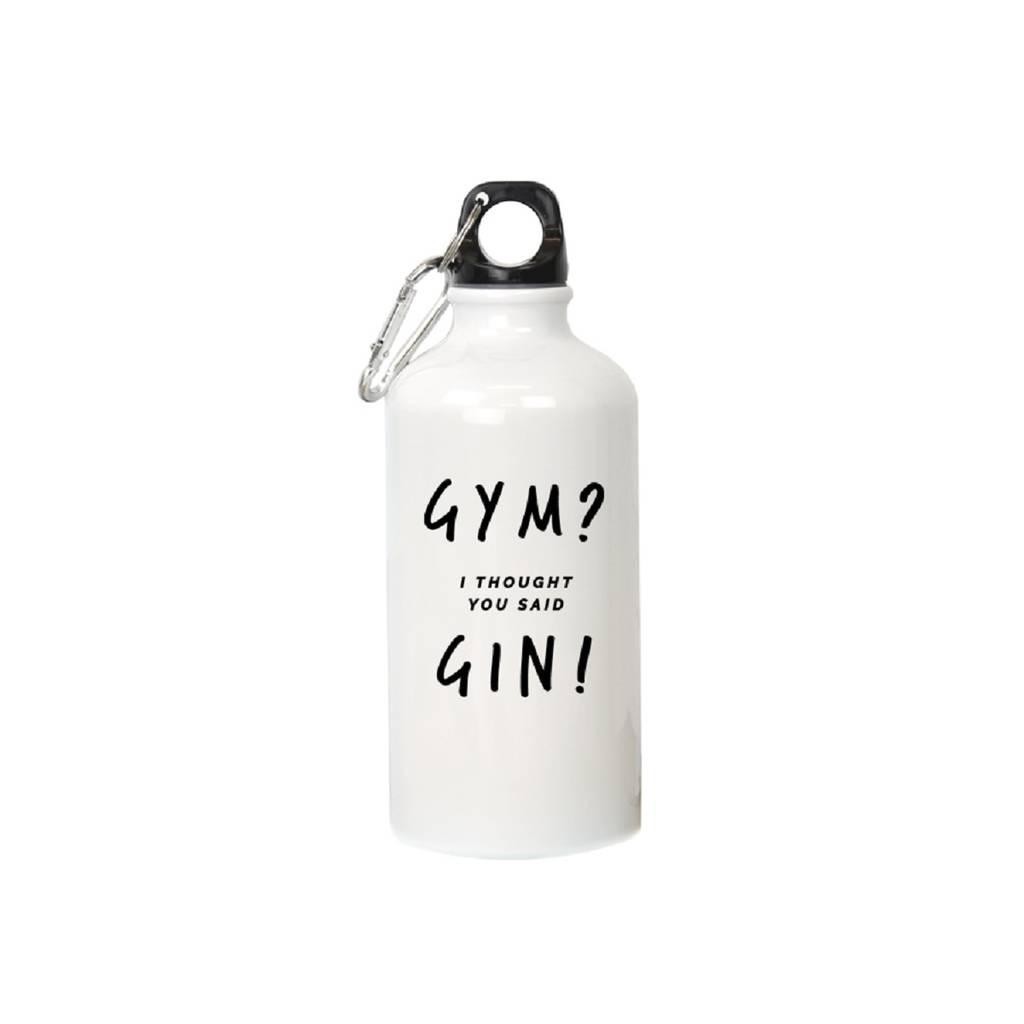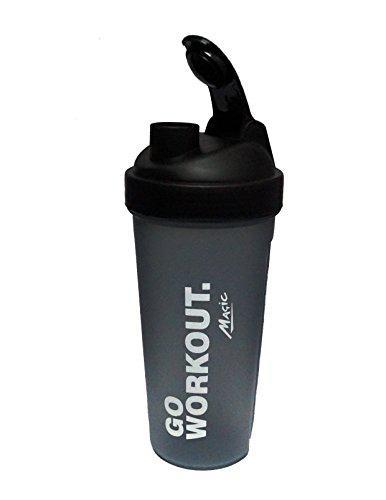The first image is the image on the left, the second image is the image on the right. Considering the images on both sides, is "At least one water bottle is jug-shaped with a built-in side handle and a flip top, and one water bottle is hot pink." valid? Answer yes or no. No. The first image is the image on the left, the second image is the image on the right. For the images displayed, is the sentence "There are three plastic drinking containers with lids." factually correct? Answer yes or no. No. 